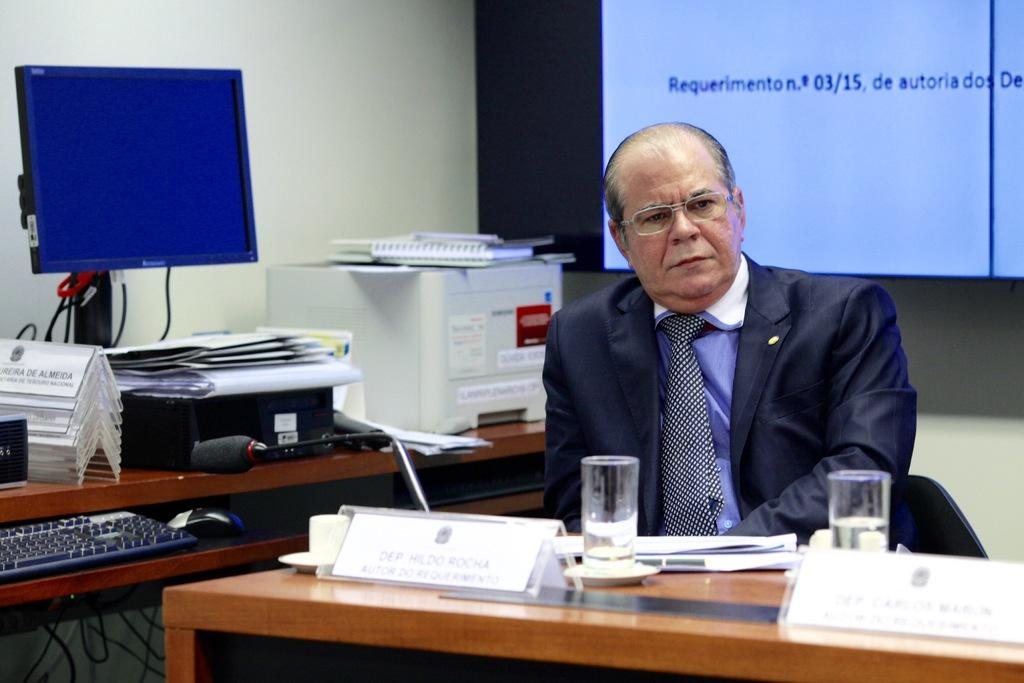What is the man in the image doing? The man is sitting in the image. Where is the man sitting in the image? The man is sitting in the top right area. What object is located on the left side of the image? There is a computer in the image. What is the computer's location in relation to the man? The computer is located on the left side. What piece of furniture is present in the image? There is a table in the image. What can be found on the table? Water glasses are present on the table. What can be seen in the background of the image? There is a screen in the background of the image. What type of substance is being used by the crowd in the image? There is no crowd present in the image, so it is not possible to determine what substance they might be using. 